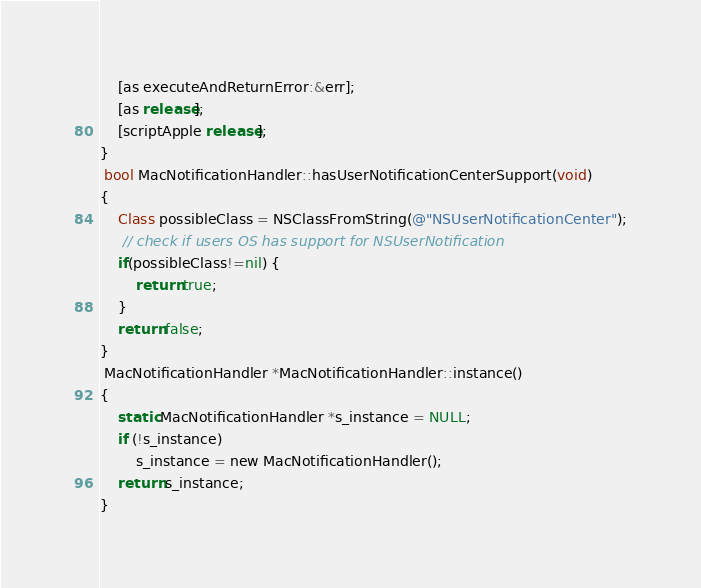Convert code to text. <code><loc_0><loc_0><loc_500><loc_500><_ObjectiveC_>    [as executeAndReturnError:&err];
    [as release];
    [scriptApple release];
}
 bool MacNotificationHandler::hasUserNotificationCenterSupport(void)
{
    Class possibleClass = NSClassFromString(@"NSUserNotificationCenter");
     // check if users OS has support for NSUserNotification
    if(possibleClass!=nil) {
        return true;
    }
    return false;
}
 MacNotificationHandler *MacNotificationHandler::instance()
{
    static MacNotificationHandler *s_instance = NULL;
    if (!s_instance)
        s_instance = new MacNotificationHandler();
    return s_instance;
}</code> 